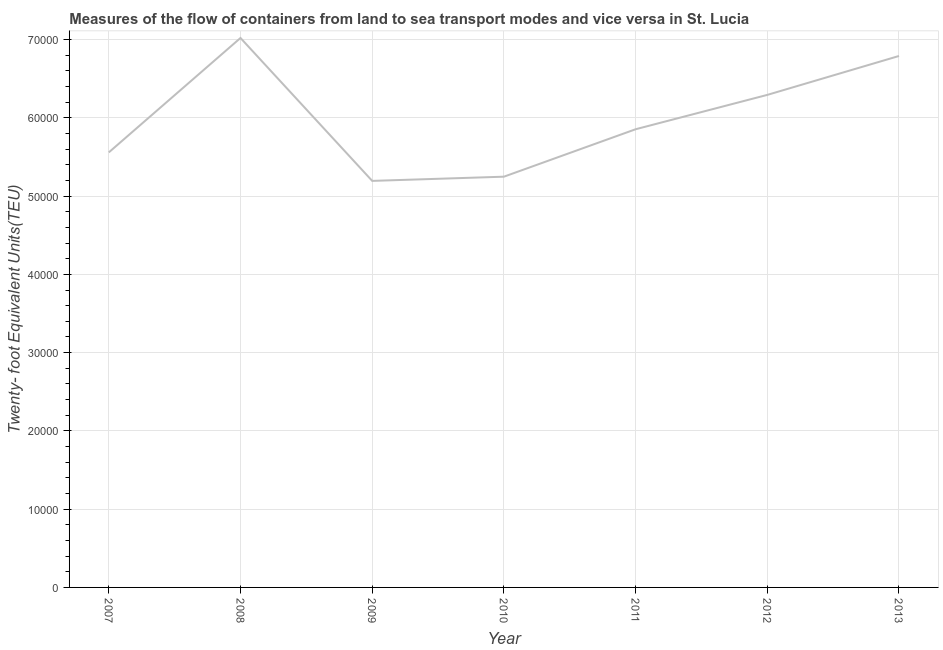What is the container port traffic in 2013?
Offer a very short reply. 6.79e+04. Across all years, what is the maximum container port traffic?
Keep it short and to the point. 7.02e+04. Across all years, what is the minimum container port traffic?
Provide a short and direct response. 5.19e+04. In which year was the container port traffic maximum?
Make the answer very short. 2008. In which year was the container port traffic minimum?
Offer a terse response. 2009. What is the sum of the container port traffic?
Ensure brevity in your answer.  4.20e+05. What is the difference between the container port traffic in 2009 and 2010?
Your answer should be very brief. -537. What is the average container port traffic per year?
Provide a short and direct response. 5.99e+04. What is the median container port traffic?
Make the answer very short. 5.85e+04. What is the ratio of the container port traffic in 2010 to that in 2013?
Your answer should be compact. 0.77. Is the container port traffic in 2008 less than that in 2009?
Make the answer very short. No. What is the difference between the highest and the second highest container port traffic?
Give a very brief answer. 2301.22. What is the difference between the highest and the lowest container port traffic?
Provide a short and direct response. 1.83e+04. Does the container port traffic monotonically increase over the years?
Provide a succinct answer. No. How many years are there in the graph?
Ensure brevity in your answer.  7. Does the graph contain grids?
Offer a terse response. Yes. What is the title of the graph?
Make the answer very short. Measures of the flow of containers from land to sea transport modes and vice versa in St. Lucia. What is the label or title of the X-axis?
Provide a succinct answer. Year. What is the label or title of the Y-axis?
Ensure brevity in your answer.  Twenty- foot Equivalent Units(TEU). What is the Twenty- foot Equivalent Units(TEU) in 2007?
Your response must be concise. 5.56e+04. What is the Twenty- foot Equivalent Units(TEU) in 2008?
Offer a very short reply. 7.02e+04. What is the Twenty- foot Equivalent Units(TEU) in 2009?
Your response must be concise. 5.19e+04. What is the Twenty- foot Equivalent Units(TEU) in 2010?
Make the answer very short. 5.25e+04. What is the Twenty- foot Equivalent Units(TEU) of 2011?
Offer a terse response. 5.85e+04. What is the Twenty- foot Equivalent Units(TEU) in 2012?
Keep it short and to the point. 6.29e+04. What is the Twenty- foot Equivalent Units(TEU) of 2013?
Give a very brief answer. 6.79e+04. What is the difference between the Twenty- foot Equivalent Units(TEU) in 2007 and 2008?
Provide a succinct answer. -1.46e+04. What is the difference between the Twenty- foot Equivalent Units(TEU) in 2007 and 2009?
Your response must be concise. 3640. What is the difference between the Twenty- foot Equivalent Units(TEU) in 2007 and 2010?
Keep it short and to the point. 3103. What is the difference between the Twenty- foot Equivalent Units(TEU) in 2007 and 2011?
Your answer should be very brief. -2956.94. What is the difference between the Twenty- foot Equivalent Units(TEU) in 2007 and 2012?
Offer a terse response. -7347.36. What is the difference between the Twenty- foot Equivalent Units(TEU) in 2007 and 2013?
Your response must be concise. -1.23e+04. What is the difference between the Twenty- foot Equivalent Units(TEU) in 2008 and 2009?
Offer a terse response. 1.83e+04. What is the difference between the Twenty- foot Equivalent Units(TEU) in 2008 and 2010?
Give a very brief answer. 1.77e+04. What is the difference between the Twenty- foot Equivalent Units(TEU) in 2008 and 2011?
Keep it short and to the point. 1.17e+04. What is the difference between the Twenty- foot Equivalent Units(TEU) in 2008 and 2012?
Your answer should be compact. 7272.64. What is the difference between the Twenty- foot Equivalent Units(TEU) in 2008 and 2013?
Offer a very short reply. 2301.22. What is the difference between the Twenty- foot Equivalent Units(TEU) in 2009 and 2010?
Make the answer very short. -537. What is the difference between the Twenty- foot Equivalent Units(TEU) in 2009 and 2011?
Provide a succinct answer. -6596.94. What is the difference between the Twenty- foot Equivalent Units(TEU) in 2009 and 2012?
Provide a succinct answer. -1.10e+04. What is the difference between the Twenty- foot Equivalent Units(TEU) in 2009 and 2013?
Your response must be concise. -1.60e+04. What is the difference between the Twenty- foot Equivalent Units(TEU) in 2010 and 2011?
Give a very brief answer. -6059.94. What is the difference between the Twenty- foot Equivalent Units(TEU) in 2010 and 2012?
Keep it short and to the point. -1.05e+04. What is the difference between the Twenty- foot Equivalent Units(TEU) in 2010 and 2013?
Ensure brevity in your answer.  -1.54e+04. What is the difference between the Twenty- foot Equivalent Units(TEU) in 2011 and 2012?
Offer a very short reply. -4390.42. What is the difference between the Twenty- foot Equivalent Units(TEU) in 2011 and 2013?
Your answer should be compact. -9361.84. What is the difference between the Twenty- foot Equivalent Units(TEU) in 2012 and 2013?
Offer a terse response. -4971.42. What is the ratio of the Twenty- foot Equivalent Units(TEU) in 2007 to that in 2008?
Provide a short and direct response. 0.79. What is the ratio of the Twenty- foot Equivalent Units(TEU) in 2007 to that in 2009?
Provide a succinct answer. 1.07. What is the ratio of the Twenty- foot Equivalent Units(TEU) in 2007 to that in 2010?
Offer a terse response. 1.06. What is the ratio of the Twenty- foot Equivalent Units(TEU) in 2007 to that in 2011?
Ensure brevity in your answer.  0.95. What is the ratio of the Twenty- foot Equivalent Units(TEU) in 2007 to that in 2012?
Ensure brevity in your answer.  0.88. What is the ratio of the Twenty- foot Equivalent Units(TEU) in 2007 to that in 2013?
Ensure brevity in your answer.  0.82. What is the ratio of the Twenty- foot Equivalent Units(TEU) in 2008 to that in 2009?
Your answer should be very brief. 1.35. What is the ratio of the Twenty- foot Equivalent Units(TEU) in 2008 to that in 2010?
Make the answer very short. 1.34. What is the ratio of the Twenty- foot Equivalent Units(TEU) in 2008 to that in 2011?
Make the answer very short. 1.2. What is the ratio of the Twenty- foot Equivalent Units(TEU) in 2008 to that in 2012?
Your response must be concise. 1.12. What is the ratio of the Twenty- foot Equivalent Units(TEU) in 2008 to that in 2013?
Offer a terse response. 1.03. What is the ratio of the Twenty- foot Equivalent Units(TEU) in 2009 to that in 2010?
Your answer should be compact. 0.99. What is the ratio of the Twenty- foot Equivalent Units(TEU) in 2009 to that in 2011?
Your answer should be compact. 0.89. What is the ratio of the Twenty- foot Equivalent Units(TEU) in 2009 to that in 2012?
Your answer should be compact. 0.82. What is the ratio of the Twenty- foot Equivalent Units(TEU) in 2009 to that in 2013?
Your answer should be compact. 0.77. What is the ratio of the Twenty- foot Equivalent Units(TEU) in 2010 to that in 2011?
Make the answer very short. 0.9. What is the ratio of the Twenty- foot Equivalent Units(TEU) in 2010 to that in 2012?
Your response must be concise. 0.83. What is the ratio of the Twenty- foot Equivalent Units(TEU) in 2010 to that in 2013?
Offer a terse response. 0.77. What is the ratio of the Twenty- foot Equivalent Units(TEU) in 2011 to that in 2013?
Make the answer very short. 0.86. What is the ratio of the Twenty- foot Equivalent Units(TEU) in 2012 to that in 2013?
Provide a succinct answer. 0.93. 